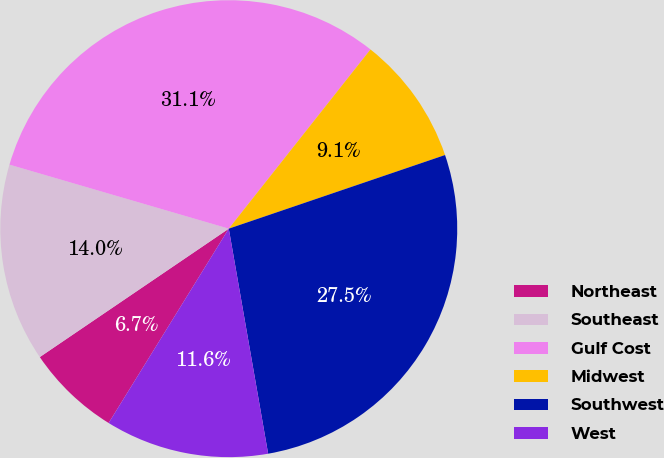<chart> <loc_0><loc_0><loc_500><loc_500><pie_chart><fcel>Northeast<fcel>Southeast<fcel>Gulf Cost<fcel>Midwest<fcel>Southwest<fcel>West<nl><fcel>6.69%<fcel>14.02%<fcel>31.13%<fcel>9.13%<fcel>27.47%<fcel>11.57%<nl></chart> 